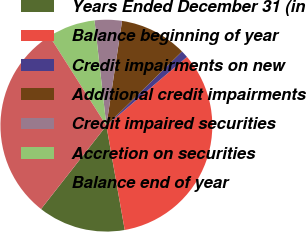Convert chart. <chart><loc_0><loc_0><loc_500><loc_500><pie_chart><fcel>Years Ended December 31 (in<fcel>Balance beginning of year<fcel>Credit impairments on new<fcel>Additional credit impairments<fcel>Credit impaired securities<fcel>Accretion on securities<fcel>Balance end of year<nl><fcel>13.35%<fcel>33.47%<fcel>1.1%<fcel>10.29%<fcel>4.16%<fcel>7.22%<fcel>30.41%<nl></chart> 